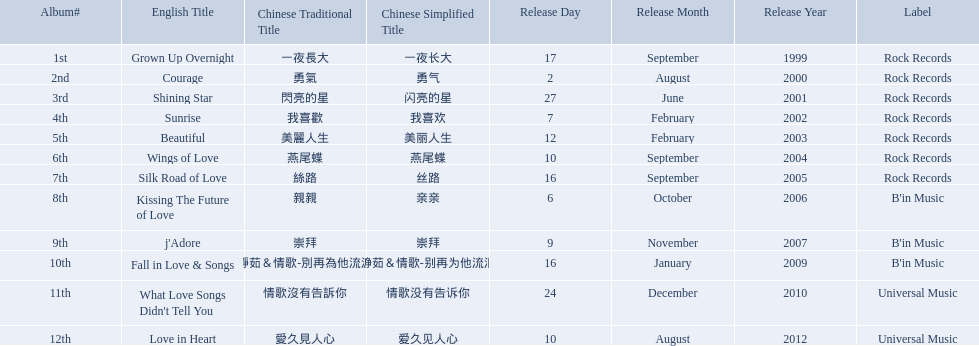Which english titles were released during even years? Courage, Sunrise, Silk Road of Love, Kissing The Future of Love, What Love Songs Didn't Tell You, Love in Heart. Out of the following, which one was released under b's in music? Kissing The Future of Love. Which songs did b'in music produce? Kissing The Future of Love, j'Adore, Fall in Love & Songs. Which one was released in an even numbered year? Kissing The Future of Love. 